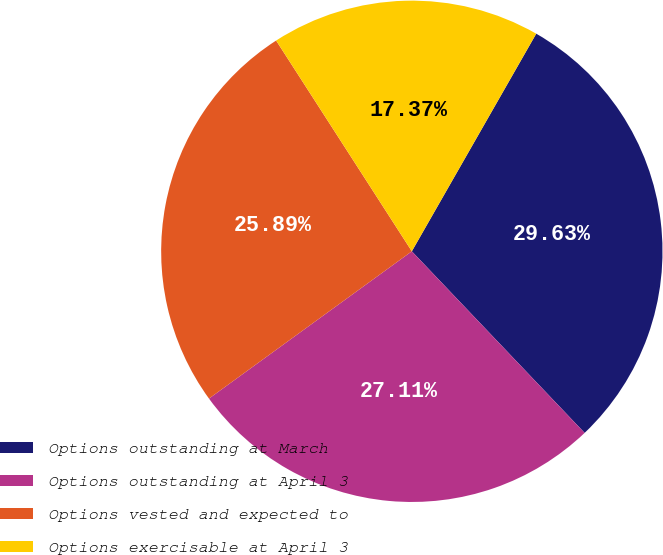<chart> <loc_0><loc_0><loc_500><loc_500><pie_chart><fcel>Options outstanding at March<fcel>Options outstanding at April 3<fcel>Options vested and expected to<fcel>Options exercisable at April 3<nl><fcel>29.63%<fcel>27.11%<fcel>25.89%<fcel>17.37%<nl></chart> 